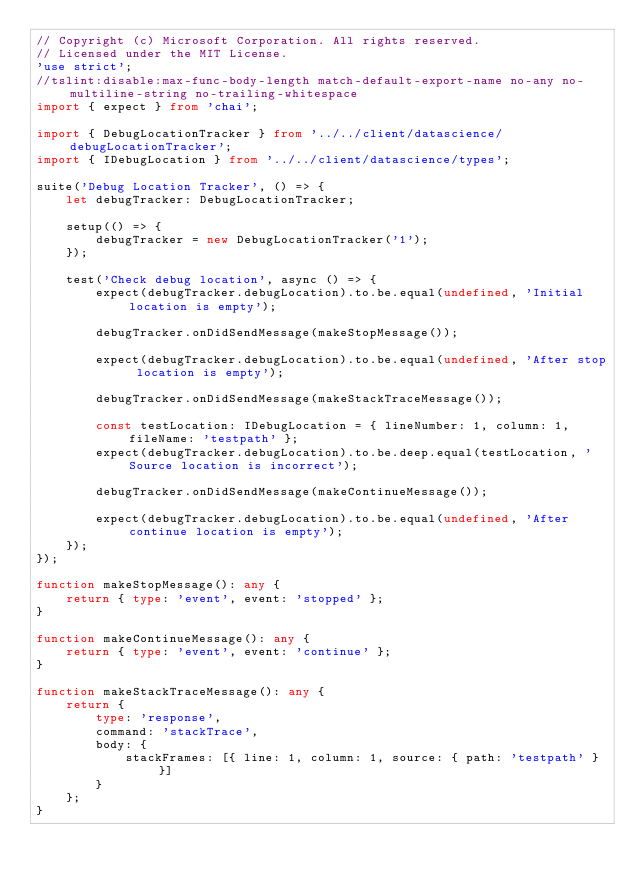<code> <loc_0><loc_0><loc_500><loc_500><_TypeScript_>// Copyright (c) Microsoft Corporation. All rights reserved.
// Licensed under the MIT License.
'use strict';
//tslint:disable:max-func-body-length match-default-export-name no-any no-multiline-string no-trailing-whitespace
import { expect } from 'chai';

import { DebugLocationTracker } from '../../client/datascience/debugLocationTracker';
import { IDebugLocation } from '../../client/datascience/types';

suite('Debug Location Tracker', () => {
    let debugTracker: DebugLocationTracker;

    setup(() => {
        debugTracker = new DebugLocationTracker('1');
    });

    test('Check debug location', async () => {
        expect(debugTracker.debugLocation).to.be.equal(undefined, 'Initial location is empty');

        debugTracker.onDidSendMessage(makeStopMessage());

        expect(debugTracker.debugLocation).to.be.equal(undefined, 'After stop location is empty');

        debugTracker.onDidSendMessage(makeStackTraceMessage());

        const testLocation: IDebugLocation = { lineNumber: 1, column: 1, fileName: 'testpath' };
        expect(debugTracker.debugLocation).to.be.deep.equal(testLocation, 'Source location is incorrect');

        debugTracker.onDidSendMessage(makeContinueMessage());

        expect(debugTracker.debugLocation).to.be.equal(undefined, 'After continue location is empty');
    });
});

function makeStopMessage(): any {
    return { type: 'event', event: 'stopped' };
}

function makeContinueMessage(): any {
    return { type: 'event', event: 'continue' };
}

function makeStackTraceMessage(): any {
    return {
        type: 'response',
        command: 'stackTrace',
        body: {
            stackFrames: [{ line: 1, column: 1, source: { path: 'testpath' } }]
        }
    };
}
</code> 